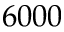<formula> <loc_0><loc_0><loc_500><loc_500>6 0 0 0</formula> 